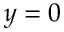Convert formula to latex. <formula><loc_0><loc_0><loc_500><loc_500>y = 0</formula> 